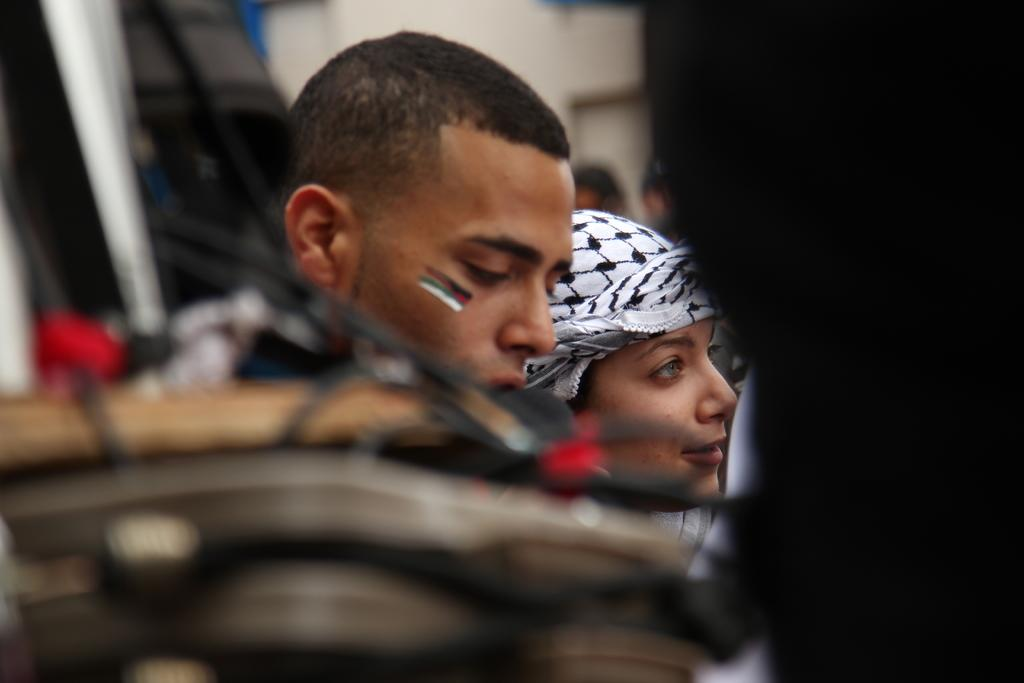What are the two main subjects in the image? There is a man and a lady in the image. Can you describe the positioning of the man and the lady in the image? Both the man and the lady are in the center of the image. Where is the jail located in the image? There is no jail present in the image. What type of point is the lady making in the image? There is no specific point being made by the lady in the image. 